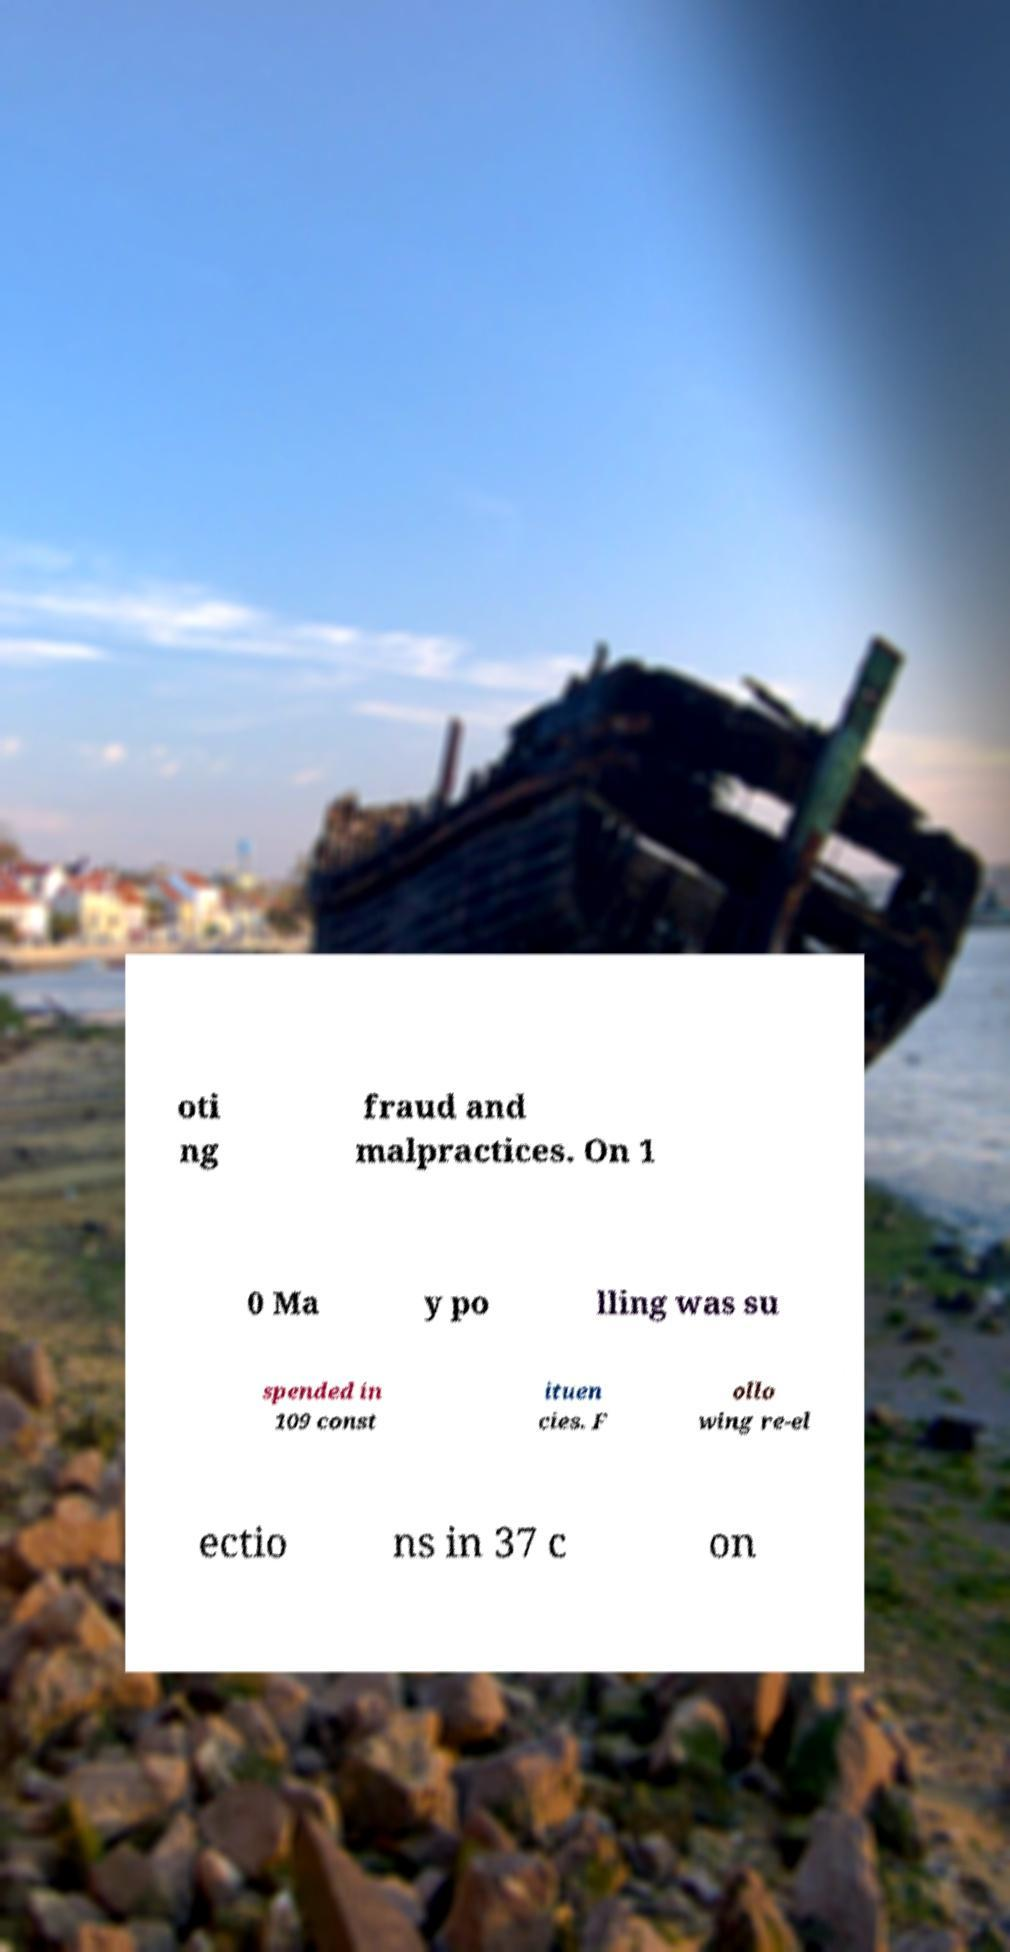Could you extract and type out the text from this image? oti ng fraud and malpractices. On 1 0 Ma y po lling was su spended in 109 const ituen cies. F ollo wing re-el ectio ns in 37 c on 